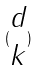Convert formula to latex. <formula><loc_0><loc_0><loc_500><loc_500>( \begin{matrix} d \\ k \end{matrix} )</formula> 